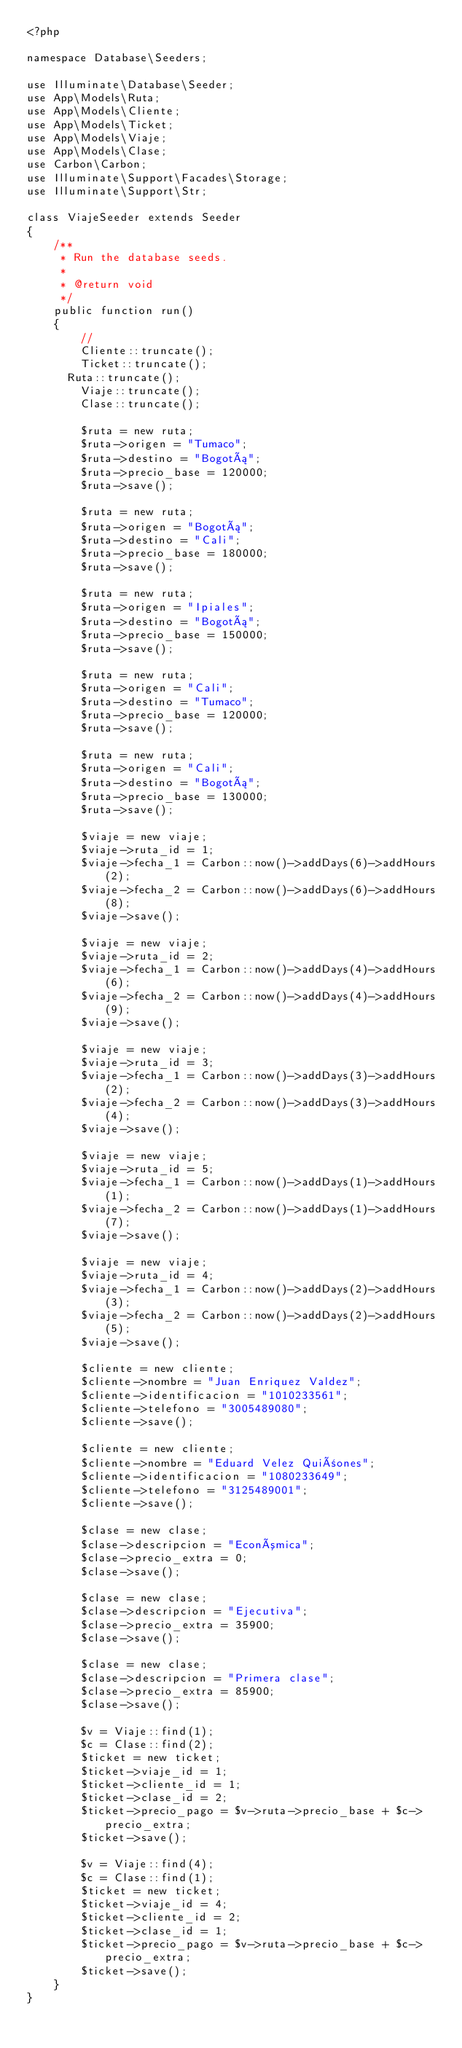<code> <loc_0><loc_0><loc_500><loc_500><_PHP_><?php

namespace Database\Seeders;

use Illuminate\Database\Seeder;
use App\Models\Ruta;
use App\Models\Cliente;
use App\Models\Ticket;
use App\Models\Viaje;
use App\Models\Clase;
use Carbon\Carbon;
use Illuminate\Support\Facades\Storage;
use Illuminate\Support\Str;

class ViajeSeeder extends Seeder
{
    /**
     * Run the database seeds.
     *
     * @return void
     */
    public function run()
    {
        //
        Cliente::truncate();
        Ticket::truncate();
    	Ruta::truncate();
        Viaje::truncate();
        Clase::truncate();

        $ruta = new ruta;
        $ruta->origen = "Tumaco";
        $ruta->destino = "Bogotá";
        $ruta->precio_base = 120000;
        $ruta->save();

        $ruta = new ruta;
        $ruta->origen = "Bogotá";
        $ruta->destino = "Cali";
        $ruta->precio_base = 180000;      
        $ruta->save();

        $ruta = new ruta;
        $ruta->origen = "Ipiales";
        $ruta->destino = "Bogotá"; 
        $ruta->precio_base = 150000;      
        $ruta->save();

        $ruta = new ruta;
        $ruta->origen = "Cali";
        $ruta->destino = "Tumaco";
        $ruta->precio_base = 120000;
        $ruta->save();

        $ruta = new ruta;
        $ruta->origen = "Cali";
        $ruta->destino = "Bogotá";
        $ruta->precio_base = 130000;
        $ruta->save();

        $viaje = new viaje;
        $viaje->ruta_id = 1;
        $viaje->fecha_1 = Carbon::now()->addDays(6)->addHours(2);
        $viaje->fecha_2 = Carbon::now()->addDays(6)->addHours(8);
        $viaje->save();

        $viaje = new viaje;
        $viaje->ruta_id = 2;
        $viaje->fecha_1 = Carbon::now()->addDays(4)->addHours(6);
        $viaje->fecha_2 = Carbon::now()->addDays(4)->addHours(9);
        $viaje->save();

        $viaje = new viaje;
        $viaje->ruta_id = 3;
        $viaje->fecha_1 = Carbon::now()->addDays(3)->addHours(2);
        $viaje->fecha_2 = Carbon::now()->addDays(3)->addHours(4);
        $viaje->save();

        $viaje = new viaje;
        $viaje->ruta_id = 5;
        $viaje->fecha_1 = Carbon::now()->addDays(1)->addHours(1);
        $viaje->fecha_2 = Carbon::now()->addDays(1)->addHours(7);
        $viaje->save();

        $viaje = new viaje;
        $viaje->ruta_id = 4;
        $viaje->fecha_1 = Carbon::now()->addDays(2)->addHours(3);
        $viaje->fecha_2 = Carbon::now()->addDays(2)->addHours(5);
        $viaje->save();

        $cliente = new cliente;
        $cliente->nombre = "Juan Enriquez Valdez";
        $cliente->identificacion = "1010233561";
        $cliente->telefono = "3005489080";
        $cliente->save();

        $cliente = new cliente;
        $cliente->nombre = "Eduard Velez Quiñones";
        $cliente->identificacion = "1080233649";
        $cliente->telefono = "3125489001";
        $cliente->save();

        $clase = new clase;
        $clase->descripcion = "Económica";
        $clase->precio_extra = 0;
        $clase->save();

        $clase = new clase;
        $clase->descripcion = "Ejecutiva";
        $clase->precio_extra = 35900;
        $clase->save();

        $clase = new clase;
        $clase->descripcion = "Primera clase";
        $clase->precio_extra = 85900;
        $clase->save();

        $v = Viaje::find(1);
        $c = Clase::find(2);
        $ticket = new ticket;
        $ticket->viaje_id = 1;
        $ticket->cliente_id = 1;
        $ticket->clase_id = 2;
        $ticket->precio_pago = $v->ruta->precio_base + $c->precio_extra;
        $ticket->save();

        $v = Viaje::find(4);
        $c = Clase::find(1);
        $ticket = new ticket;
        $ticket->viaje_id = 4;
        $ticket->cliente_id = 2;
        $ticket->clase_id = 1;
        $ticket->precio_pago = $v->ruta->precio_base + $c->precio_extra;
        $ticket->save();
    }
}
</code> 